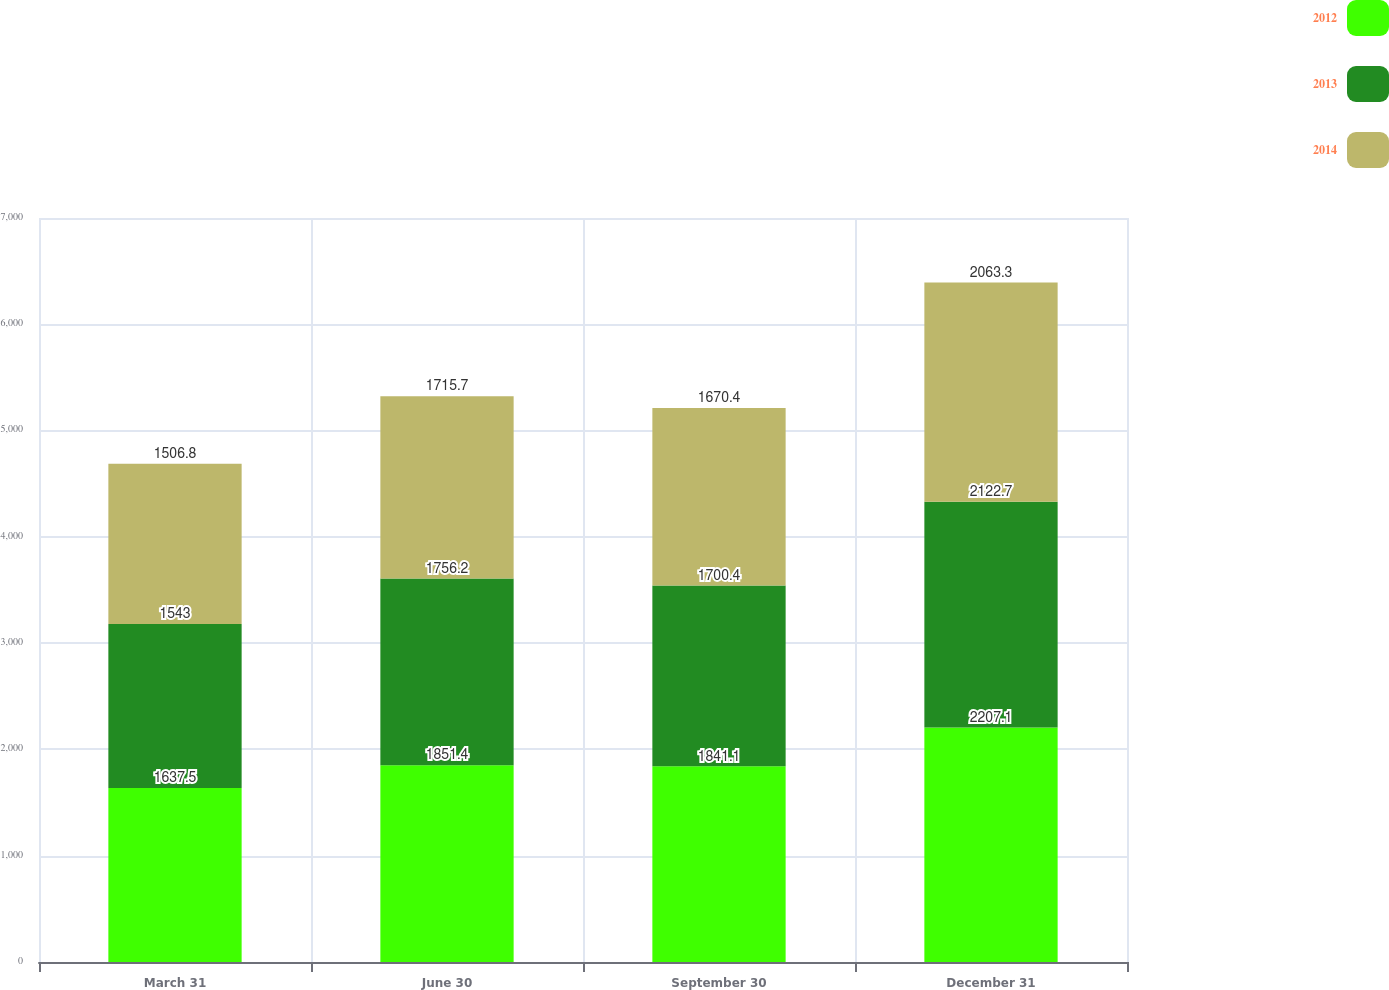<chart> <loc_0><loc_0><loc_500><loc_500><stacked_bar_chart><ecel><fcel>March 31<fcel>June 30<fcel>September 30<fcel>December 31<nl><fcel>2012<fcel>1637.5<fcel>1851.4<fcel>1841.1<fcel>2207.1<nl><fcel>2013<fcel>1543<fcel>1756.2<fcel>1700.4<fcel>2122.7<nl><fcel>2014<fcel>1506.8<fcel>1715.7<fcel>1670.4<fcel>2063.3<nl></chart> 